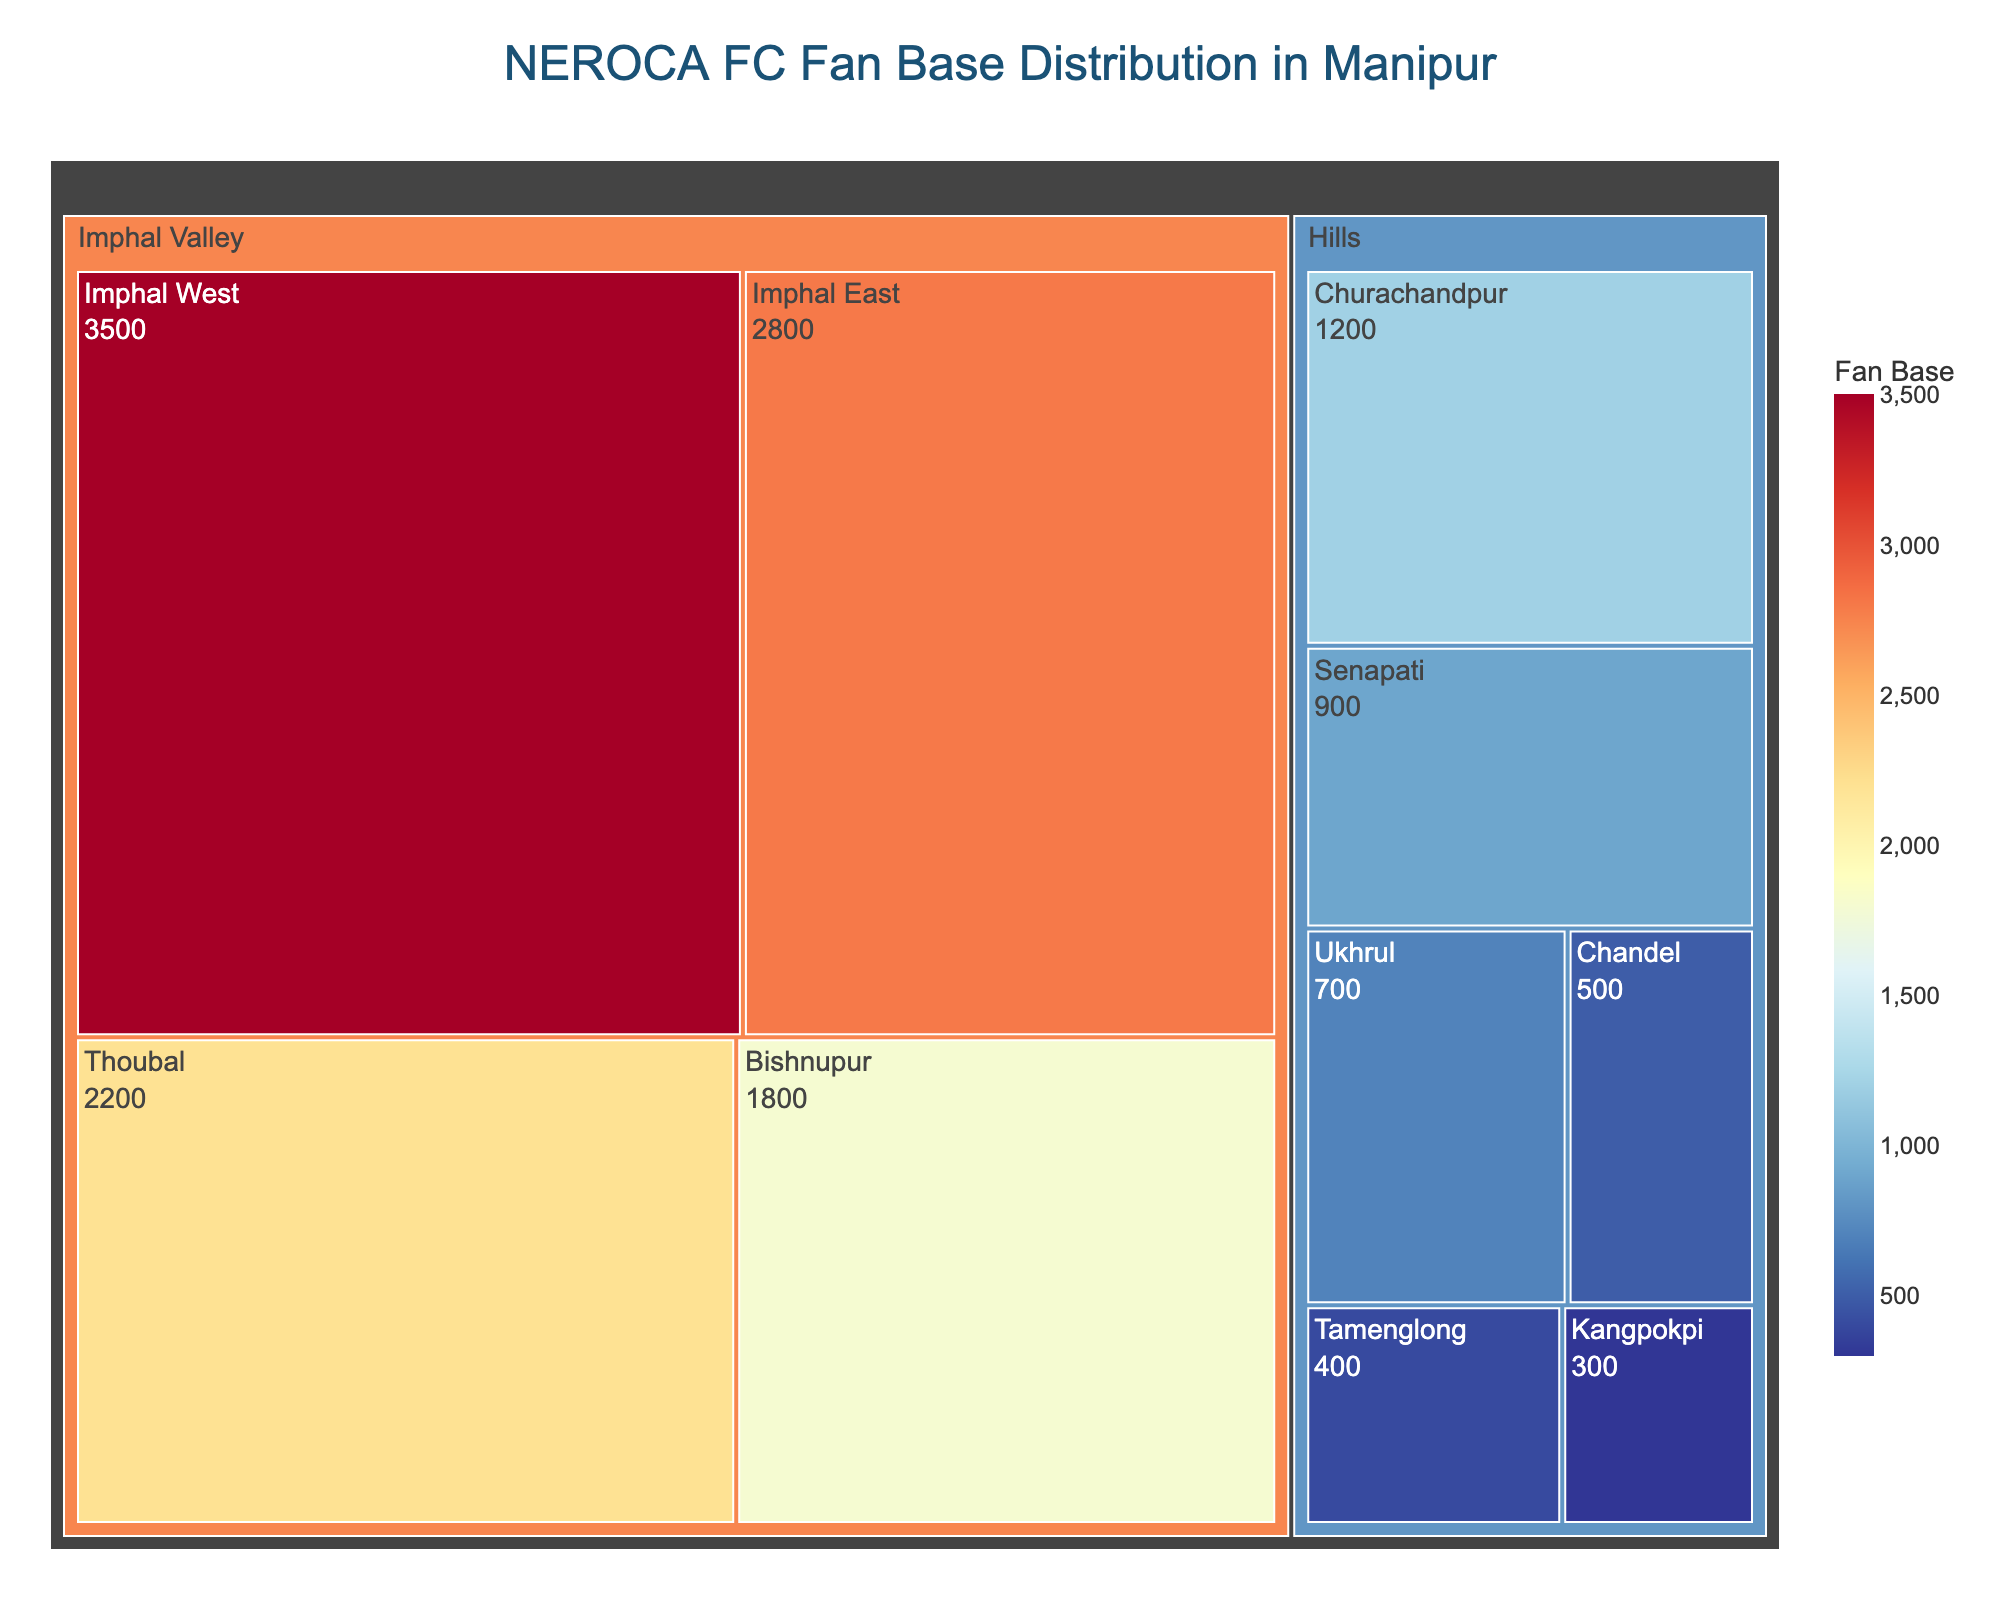What is the title of the figure? The title of the figure is prominently displayed at the top center. It reads "NEROCA FC Fan Base Distribution in Manipur."
Answer: NEROCA FC Fan Base Distribution in Manipur Which district has the largest fan base? To find the district with the largest fan base, look for the area in the treemap with the highest value labeled. The district with the largest fan base is Imphal West.
Answer: Imphal West How many fans are there in the Hills region? Sum the fan base of all districts under the Hills region: 1200 (Churachandpur) + 900 (Senapati) + 700 (Ukhrul) + 500 (Chandel) + 400 (Tamenglong) + 300 (Kangpokpi) = 4000.
Answer: 4000 Which district in the Imphal Valley region has the smallest fan base? Among the districts in the Imphal Valley region, Bishnupur has the smallest fan base, as seen from its smaller area in the treemap with a value of 1800.
Answer: Bishnupur How does the fan base of Imphal East compare to that of Thoubal? Imphal East has a fan base of 2800, and Thoubal has a fan base of 2200. To compare, 2800 is greater than 2200.
Answer: Imphal East has more fans What is the combined fan base of Imphal Valley and Hills regions? Sum the fan base of all districts in both regions: Imphal Valley (3500 + 2800 + 2200 + 1800) + Hills (1200 + 900 + 700 + 500 + 400 + 300) = 10300 + 4000 = 14300.
Answer: 14300 What percentage of the total fan base does Churachandpur represent? First, find the total fan base: 14300. Churachandpur fan base is 1200. The percentage is (1200 / 14300) * 100 ≈ 8.39%.
Answer: 8.39% Which two districts have a combined fan base greater than 5000? Look for pairs of districts where the sum of their fan bases exceeds 5000. Imphal West (3500) and Imphal East (2800) combined is 6300, which is greater than 5000.
Answer: Imphal West and Imphal East What is the average fan base of the districts in the Hills region? Sum the fan base of all Hills districts and divide by the number of districts: (1200 + 900 + 700 + 500 + 400 + 300) / 6 = 4000 / 6 ≈ 666.67.
Answer: 666.67 Which district has nearly double the fan base of Ukhrul? Ukhrul has a fan base of 700. Doubling 700 gives 1400. The district closest to this value is Churachandpur with 1200.
Answer: Churachandpur 